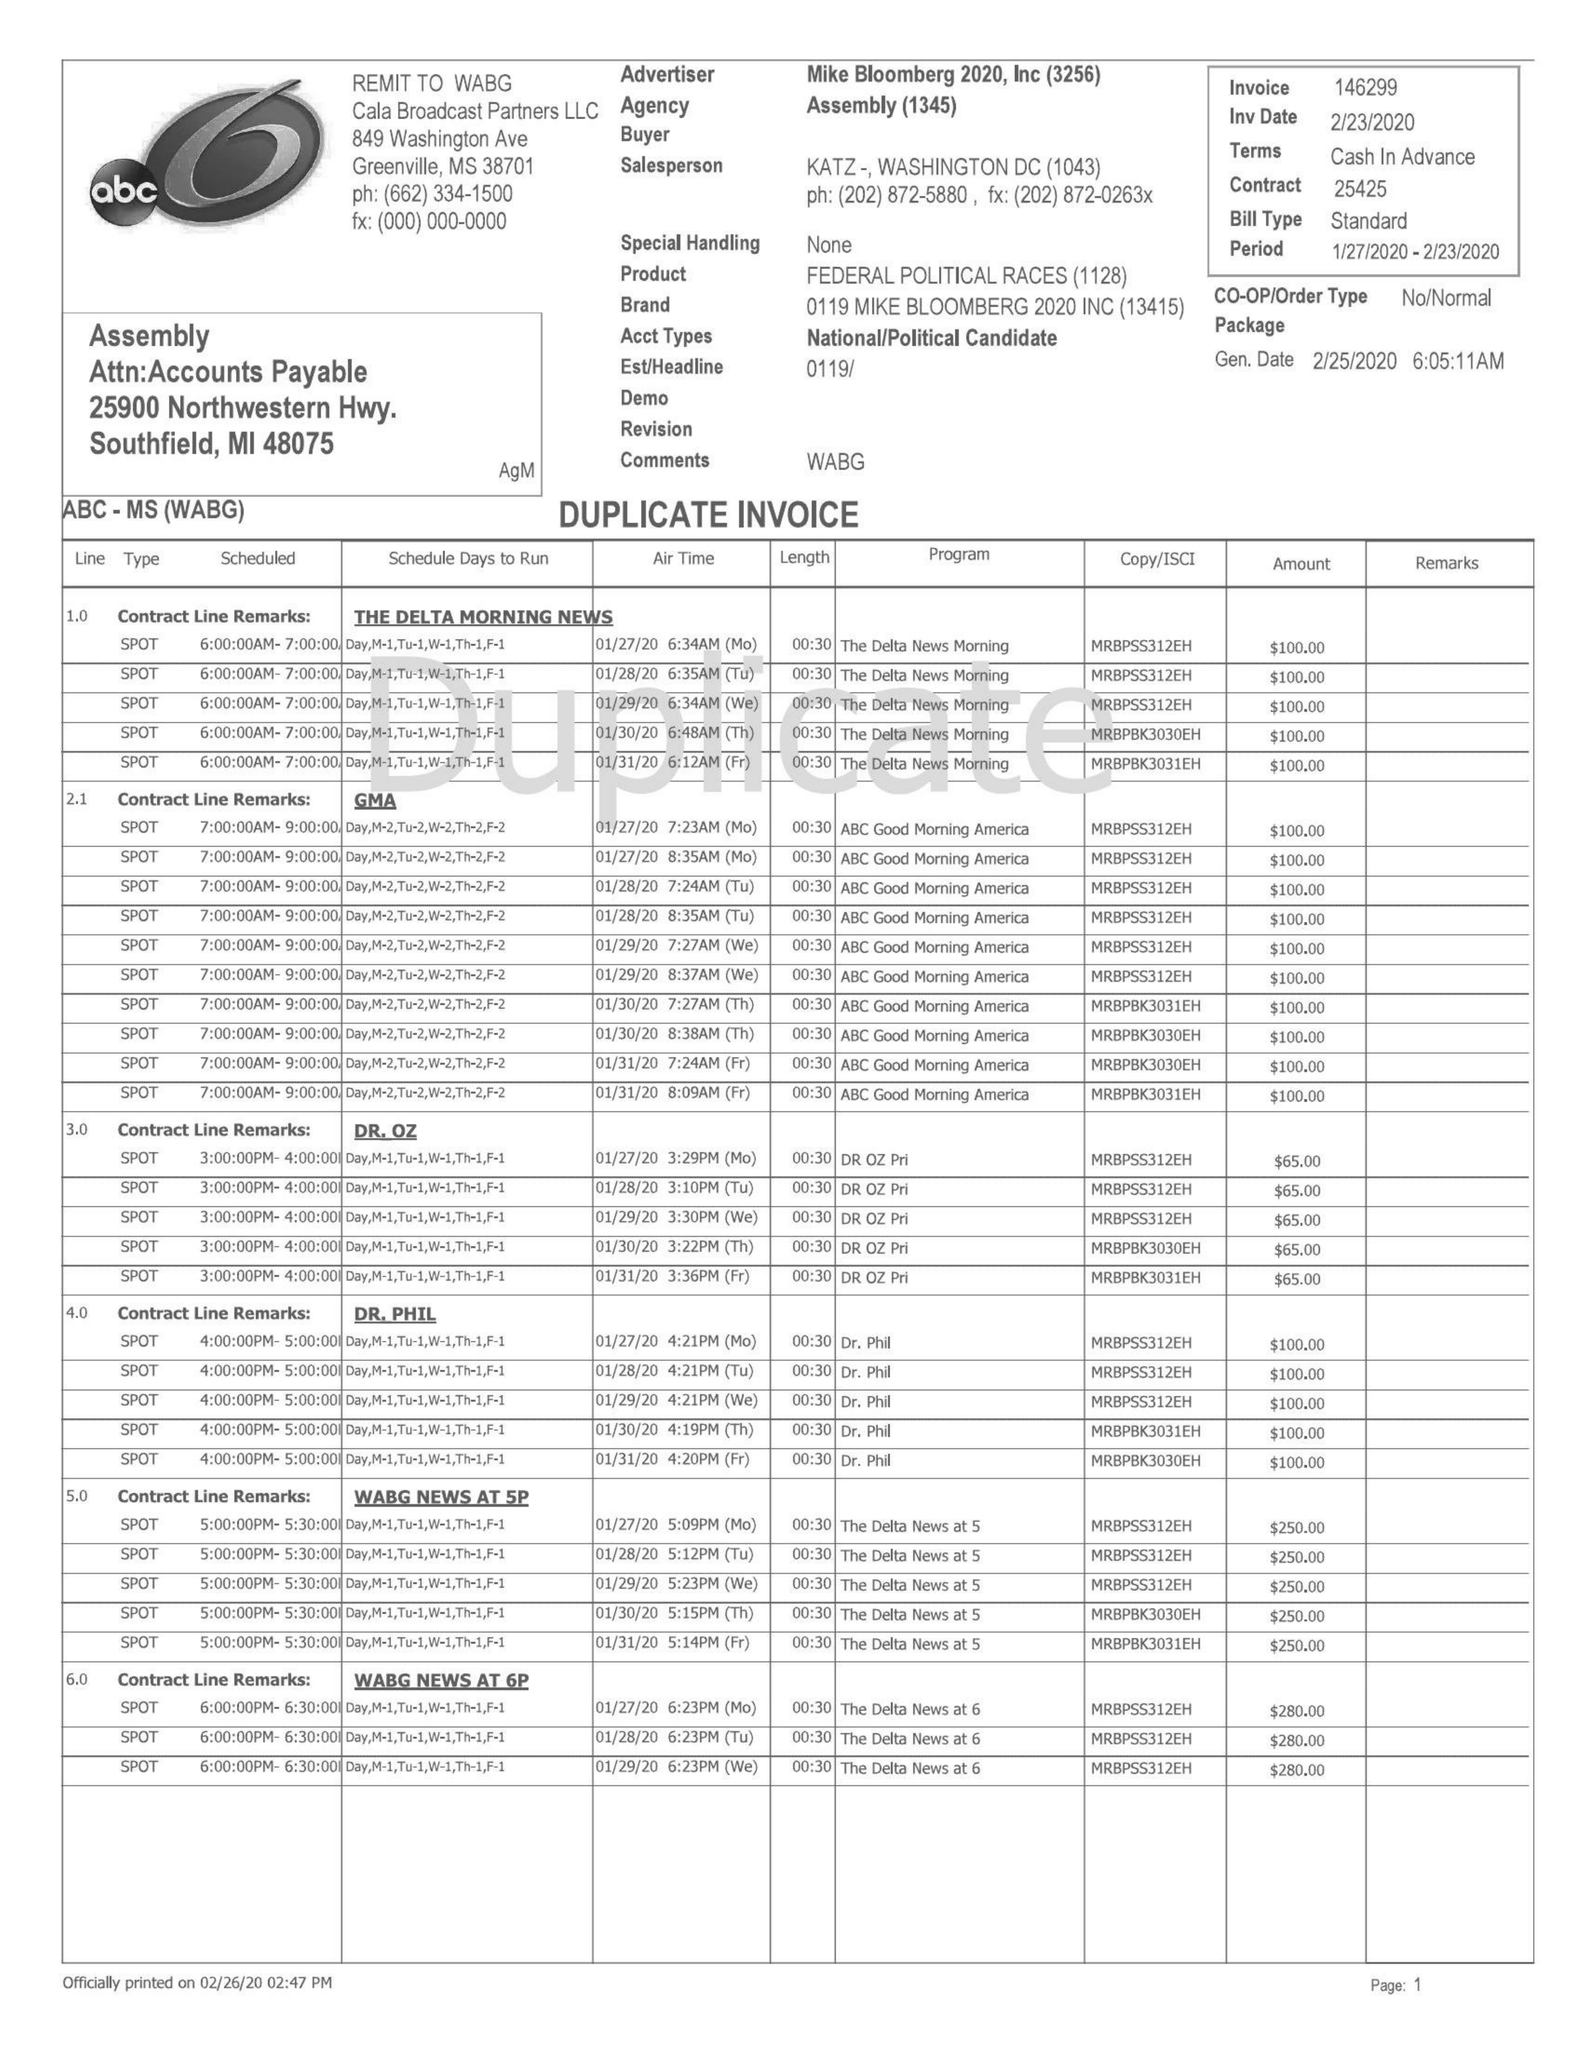What is the value for the gross_amount?
Answer the question using a single word or phrase. 65285.00 